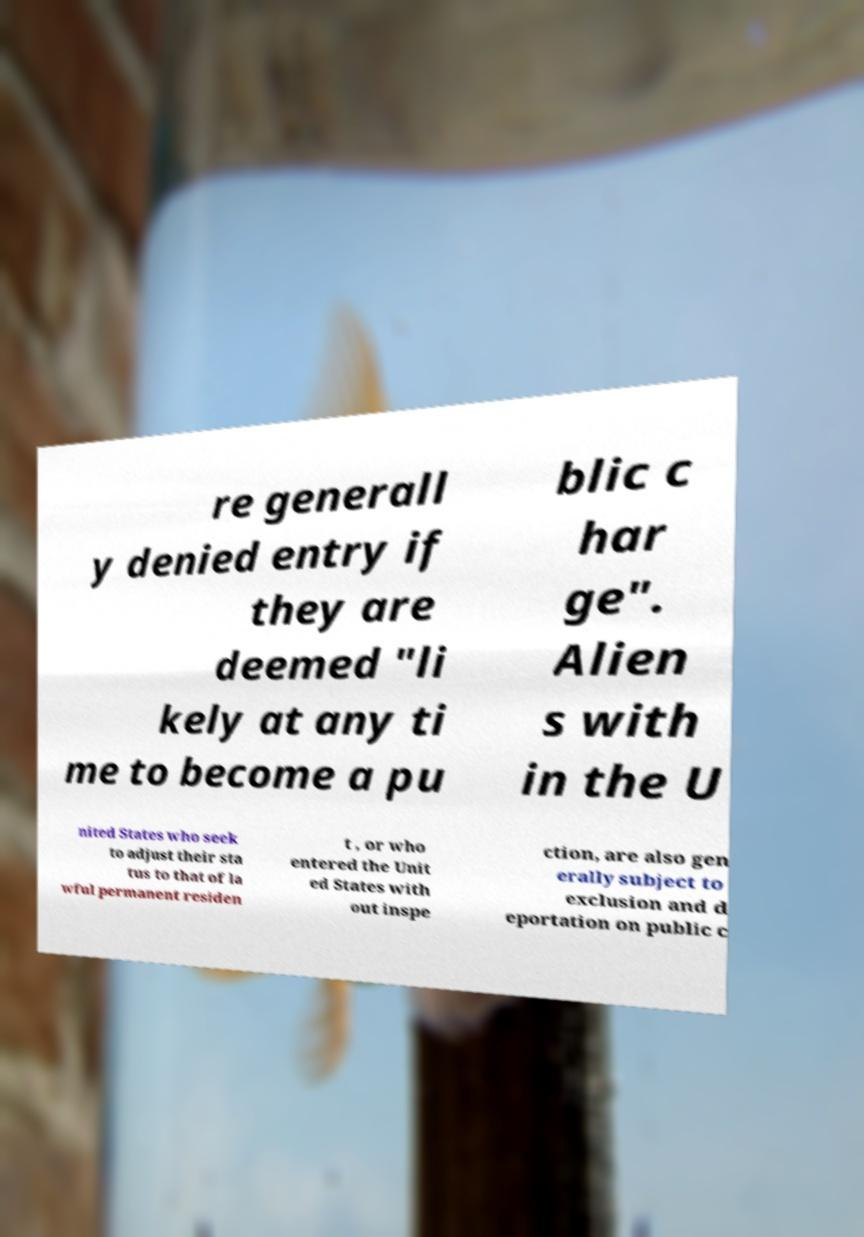Can you read and provide the text displayed in the image?This photo seems to have some interesting text. Can you extract and type it out for me? re generall y denied entry if they are deemed "li kely at any ti me to become a pu blic c har ge". Alien s with in the U nited States who seek to adjust their sta tus to that of la wful permanent residen t , or who entered the Unit ed States with out inspe ction, are also gen erally subject to exclusion and d eportation on public c 